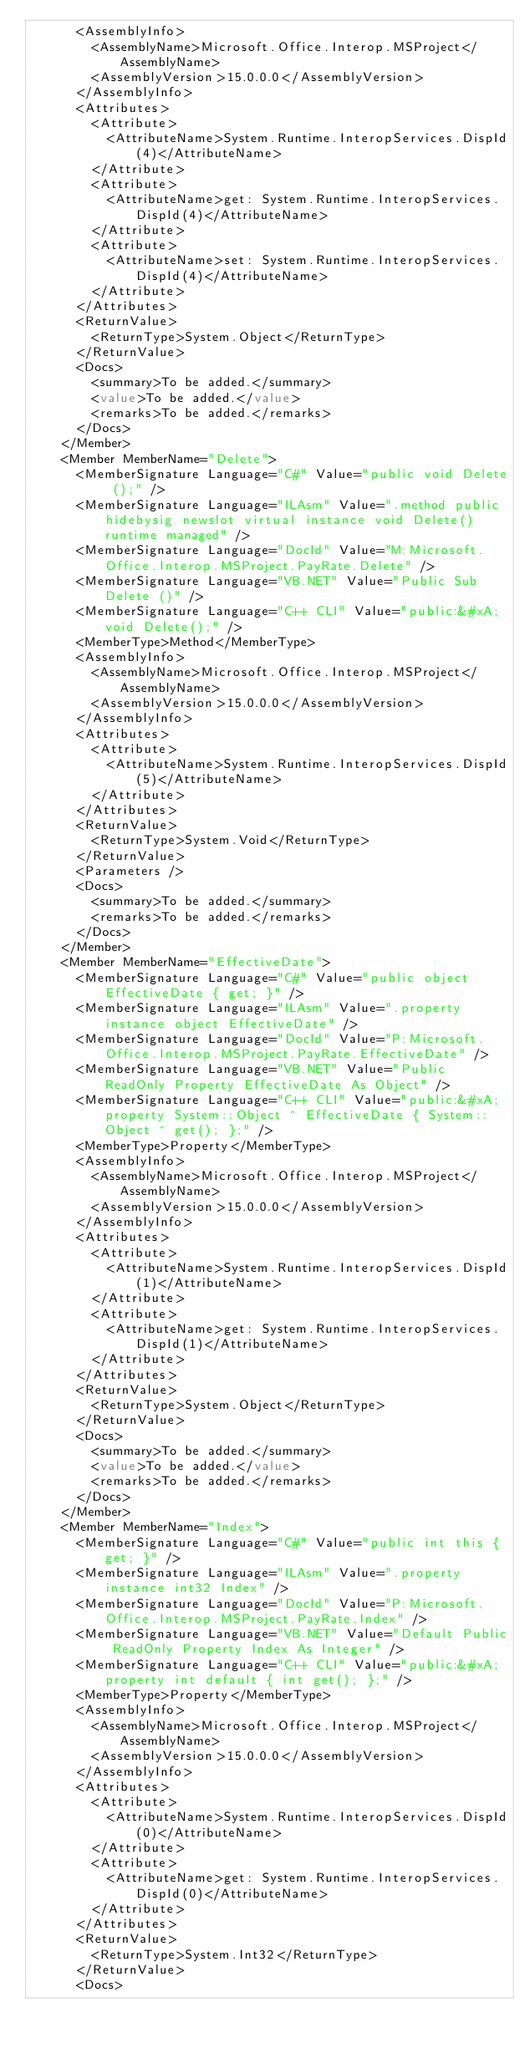Convert code to text. <code><loc_0><loc_0><loc_500><loc_500><_XML_>      <AssemblyInfo>
        <AssemblyName>Microsoft.Office.Interop.MSProject</AssemblyName>
        <AssemblyVersion>15.0.0.0</AssemblyVersion>
      </AssemblyInfo>
      <Attributes>
        <Attribute>
          <AttributeName>System.Runtime.InteropServices.DispId(4)</AttributeName>
        </Attribute>
        <Attribute>
          <AttributeName>get: System.Runtime.InteropServices.DispId(4)</AttributeName>
        </Attribute>
        <Attribute>
          <AttributeName>set: System.Runtime.InteropServices.DispId(4)</AttributeName>
        </Attribute>
      </Attributes>
      <ReturnValue>
        <ReturnType>System.Object</ReturnType>
      </ReturnValue>
      <Docs>
        <summary>To be added.</summary>
        <value>To be added.</value>
        <remarks>To be added.</remarks>
      </Docs>
    </Member>
    <Member MemberName="Delete">
      <MemberSignature Language="C#" Value="public void Delete ();" />
      <MemberSignature Language="ILAsm" Value=".method public hidebysig newslot virtual instance void Delete() runtime managed" />
      <MemberSignature Language="DocId" Value="M:Microsoft.Office.Interop.MSProject.PayRate.Delete" />
      <MemberSignature Language="VB.NET" Value="Public Sub Delete ()" />
      <MemberSignature Language="C++ CLI" Value="public:&#xA; void Delete();" />
      <MemberType>Method</MemberType>
      <AssemblyInfo>
        <AssemblyName>Microsoft.Office.Interop.MSProject</AssemblyName>
        <AssemblyVersion>15.0.0.0</AssemblyVersion>
      </AssemblyInfo>
      <Attributes>
        <Attribute>
          <AttributeName>System.Runtime.InteropServices.DispId(5)</AttributeName>
        </Attribute>
      </Attributes>
      <ReturnValue>
        <ReturnType>System.Void</ReturnType>
      </ReturnValue>
      <Parameters />
      <Docs>
        <summary>To be added.</summary>
        <remarks>To be added.</remarks>
      </Docs>
    </Member>
    <Member MemberName="EffectiveDate">
      <MemberSignature Language="C#" Value="public object EffectiveDate { get; }" />
      <MemberSignature Language="ILAsm" Value=".property instance object EffectiveDate" />
      <MemberSignature Language="DocId" Value="P:Microsoft.Office.Interop.MSProject.PayRate.EffectiveDate" />
      <MemberSignature Language="VB.NET" Value="Public ReadOnly Property EffectiveDate As Object" />
      <MemberSignature Language="C++ CLI" Value="public:&#xA; property System::Object ^ EffectiveDate { System::Object ^ get(); };" />
      <MemberType>Property</MemberType>
      <AssemblyInfo>
        <AssemblyName>Microsoft.Office.Interop.MSProject</AssemblyName>
        <AssemblyVersion>15.0.0.0</AssemblyVersion>
      </AssemblyInfo>
      <Attributes>
        <Attribute>
          <AttributeName>System.Runtime.InteropServices.DispId(1)</AttributeName>
        </Attribute>
        <Attribute>
          <AttributeName>get: System.Runtime.InteropServices.DispId(1)</AttributeName>
        </Attribute>
      </Attributes>
      <ReturnValue>
        <ReturnType>System.Object</ReturnType>
      </ReturnValue>
      <Docs>
        <summary>To be added.</summary>
        <value>To be added.</value>
        <remarks>To be added.</remarks>
      </Docs>
    </Member>
    <Member MemberName="Index">
      <MemberSignature Language="C#" Value="public int this { get; }" />
      <MemberSignature Language="ILAsm" Value=".property instance int32 Index" />
      <MemberSignature Language="DocId" Value="P:Microsoft.Office.Interop.MSProject.PayRate.Index" />
      <MemberSignature Language="VB.NET" Value="Default Public ReadOnly Property Index As Integer" />
      <MemberSignature Language="C++ CLI" Value="public:&#xA; property int default { int get(); };" />
      <MemberType>Property</MemberType>
      <AssemblyInfo>
        <AssemblyName>Microsoft.Office.Interop.MSProject</AssemblyName>
        <AssemblyVersion>15.0.0.0</AssemblyVersion>
      </AssemblyInfo>
      <Attributes>
        <Attribute>
          <AttributeName>System.Runtime.InteropServices.DispId(0)</AttributeName>
        </Attribute>
        <Attribute>
          <AttributeName>get: System.Runtime.InteropServices.DispId(0)</AttributeName>
        </Attribute>
      </Attributes>
      <ReturnValue>
        <ReturnType>System.Int32</ReturnType>
      </ReturnValue>
      <Docs></code> 